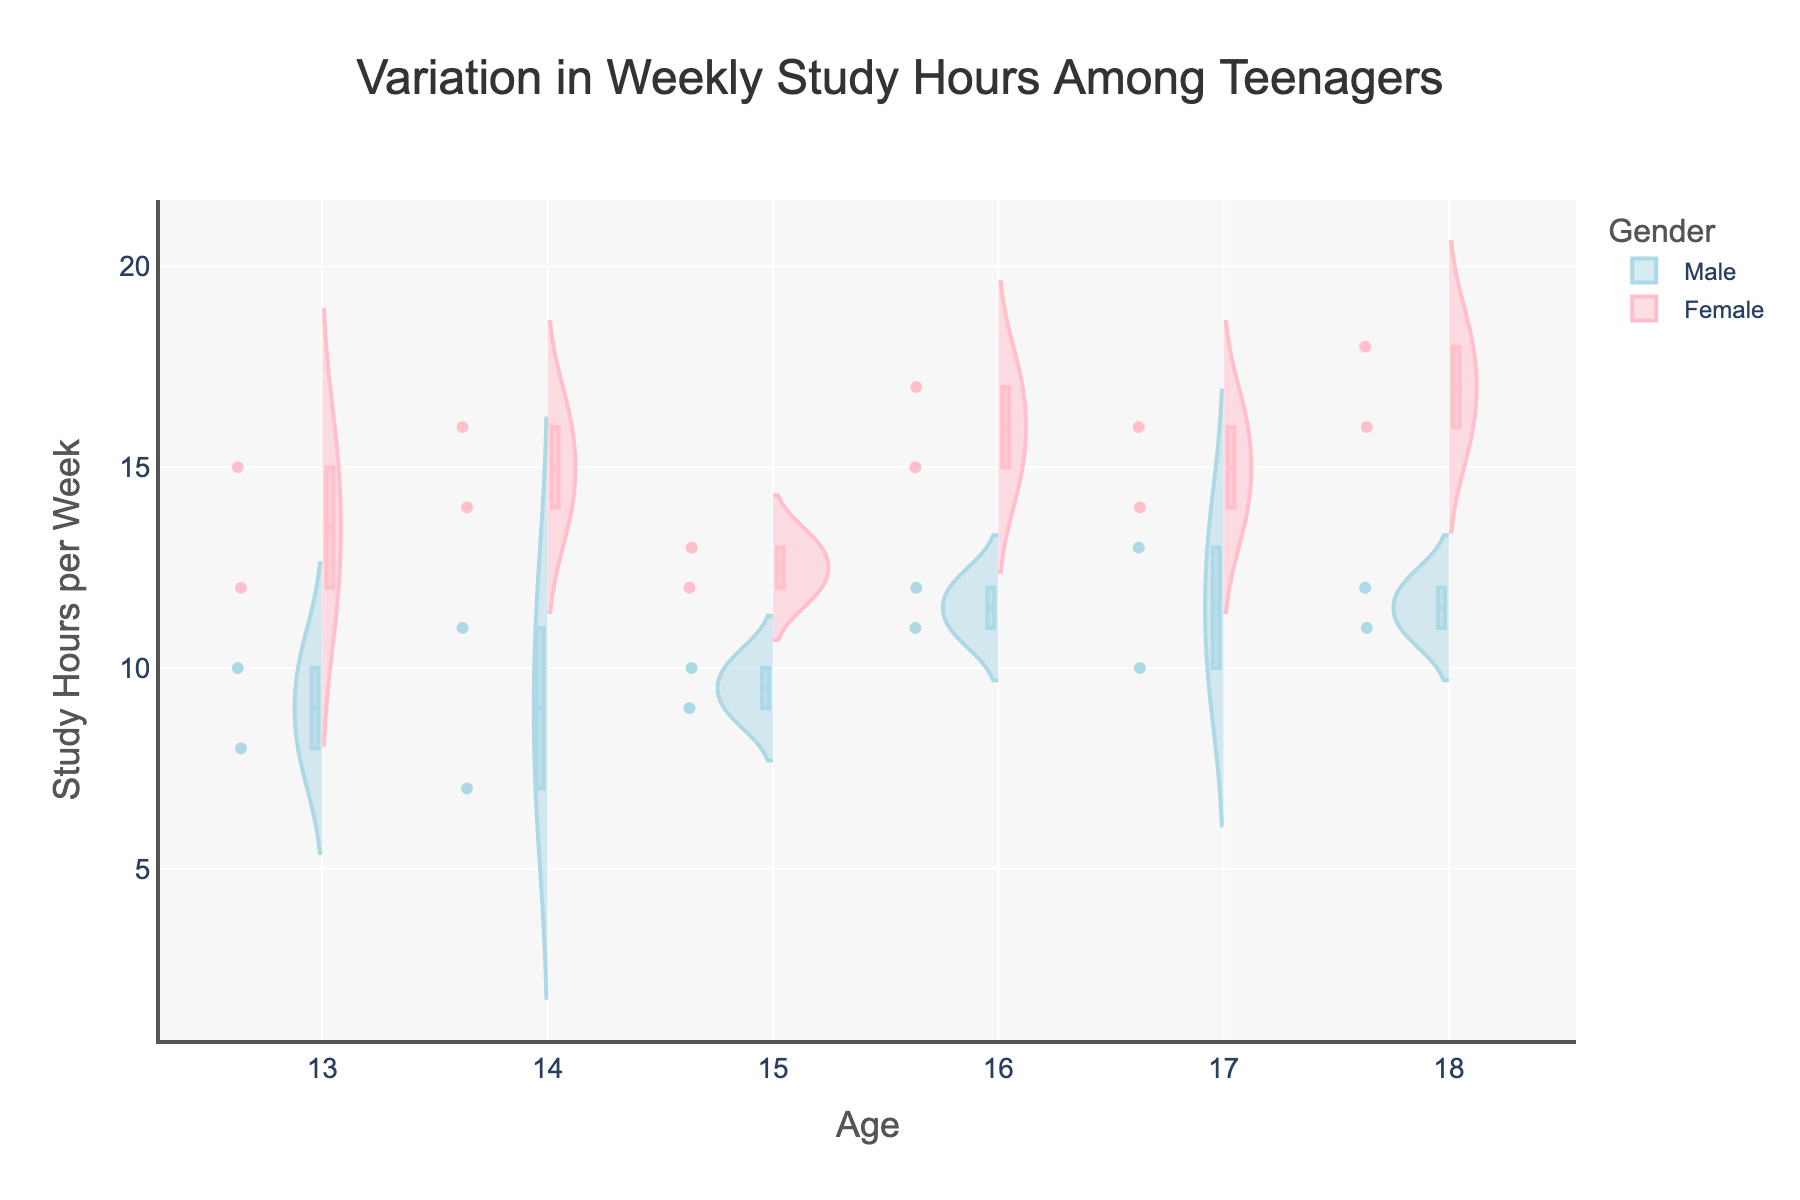How does the variation in study hours between males and females change as teenagers get older? Looking at the violin plots, we can observe the spread of study hours for each gender at different ages. Generally, both males and females show an increase in study hours with age, but females tend to have a higher and more stable variation in study hours compared to males.
Answer: Females have higher and more stable variation as they age Which gender has a higher median study hours at age 14? The box plots within the violin charts show the median values. At age 14, the median line in the female's box plot is higher than the median line in the male's box plot.
Answer: Females What is the range of study hours for 15-year-old males? The range can be identified from the spread of the violin plot at age 15 for males. It ranges from the minimum to the maximum value shown. The lowest point is 9 and the highest is 10.
Answer: 1 hour (9-10 hours) How do the study hours of 17-year-old females compare to 17-year-old males? By comparing the box plots and the spread of the violin plots for 17-year-olds, it is clear that the study hours for females are higher overall and have a less varied spread compared to males.
Answer: Females study more and have less variation What is the mean study hours for 16-year-old males? The mean can be identified from the mean line within the box plot in the male's violin chart at age 16. This line indicates an average study hours of around 11.5 per week.
Answer: 11.5 hours Which age group shows the highest variability in study hours for males? Variability can be observed from the width of the violin plots. The age 13 group for males shows a wider spread, indicating higher variability in study hours.
Answer: Age 13 At which age do females have the lowest median study hours? Medians are indicated by the central line in the box plots. For females, the median is lowest at age 13 compared to other age groups.
Answer: Age 13 Does the interquartile range (IQR) of study hours for 18-year-old females differ significantly from 18-year-old males? Looking at the box plots of 18-year-olds, the length of the box (which represents the IQR) for females is slightly smaller than that for males, indicating less spread in the middle 50% of the data.
Answer: Yes, females have a smaller IQR 